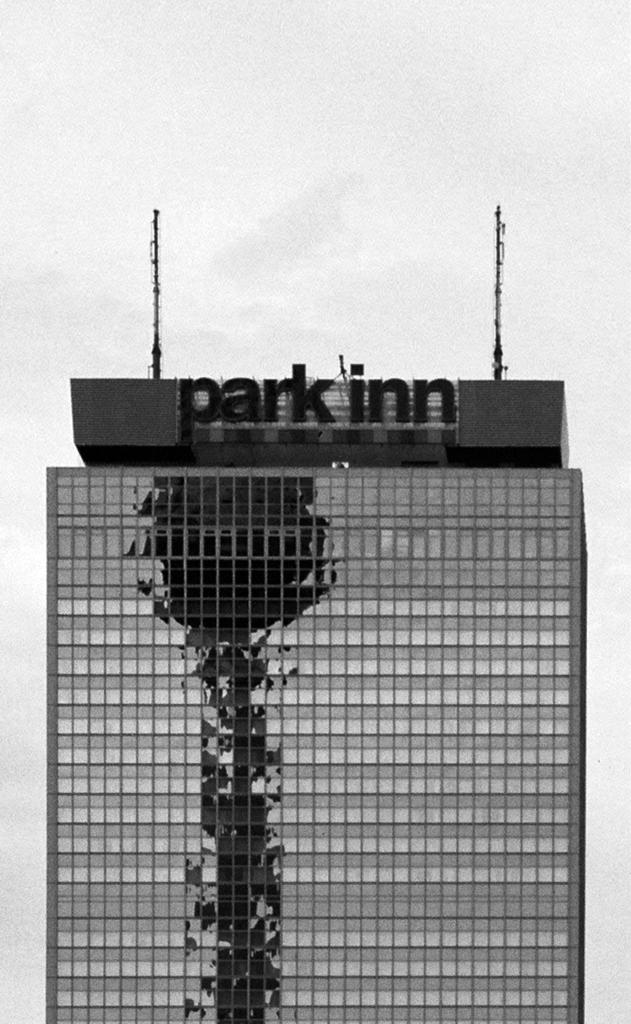What type of structure is visible in the image? There is a building in the image. What can be seen on the building? There are poles on the building. What type of silverware is being used by the person in the image? There is no person or silverware present in the image; it only features a building with poles. 